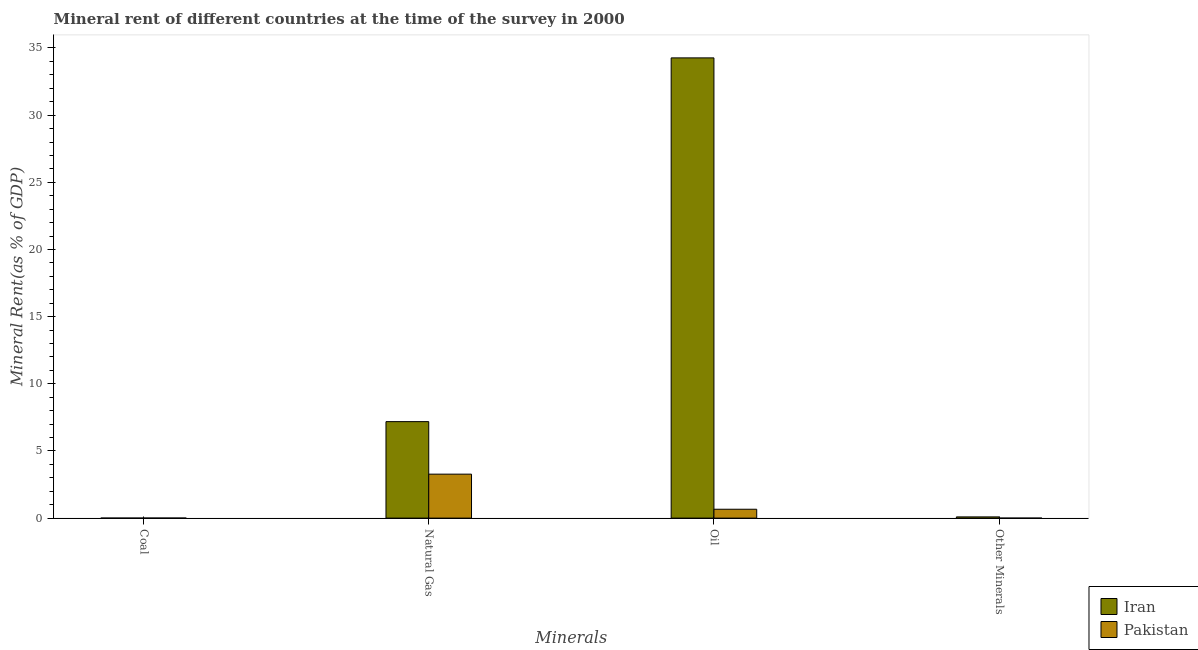How many different coloured bars are there?
Provide a short and direct response. 2. Are the number of bars per tick equal to the number of legend labels?
Give a very brief answer. Yes. How many bars are there on the 2nd tick from the left?
Your answer should be compact. 2. How many bars are there on the 1st tick from the right?
Offer a very short reply. 2. What is the label of the 2nd group of bars from the left?
Offer a very short reply. Natural Gas. What is the  rent of other minerals in Iran?
Keep it short and to the point. 0.09. Across all countries, what is the maximum oil rent?
Keep it short and to the point. 34.26. Across all countries, what is the minimum natural gas rent?
Provide a succinct answer. 3.27. In which country was the  rent of other minerals maximum?
Your response must be concise. Iran. In which country was the  rent of other minerals minimum?
Keep it short and to the point. Pakistan. What is the total natural gas rent in the graph?
Your answer should be compact. 10.46. What is the difference between the oil rent in Pakistan and that in Iran?
Provide a succinct answer. -33.6. What is the difference between the oil rent in Pakistan and the coal rent in Iran?
Provide a short and direct response. 0.66. What is the average natural gas rent per country?
Provide a short and direct response. 5.23. What is the difference between the coal rent and oil rent in Pakistan?
Your answer should be compact. -0.66. In how many countries, is the oil rent greater than 11 %?
Your answer should be compact. 1. What is the ratio of the coal rent in Pakistan to that in Iran?
Provide a short and direct response. 1.84. Is the  rent of other minerals in Iran less than that in Pakistan?
Offer a terse response. No. What is the difference between the highest and the second highest  rent of other minerals?
Provide a succinct answer. 0.09. What is the difference between the highest and the lowest coal rent?
Your answer should be very brief. 0. Is the sum of the oil rent in Iran and Pakistan greater than the maximum  rent of other minerals across all countries?
Offer a very short reply. Yes. Is it the case that in every country, the sum of the coal rent and natural gas rent is greater than the sum of  rent of other minerals and oil rent?
Give a very brief answer. No. What does the 2nd bar from the right in Coal represents?
Provide a short and direct response. Iran. Is it the case that in every country, the sum of the coal rent and natural gas rent is greater than the oil rent?
Your response must be concise. No. How many countries are there in the graph?
Offer a very short reply. 2. Are the values on the major ticks of Y-axis written in scientific E-notation?
Provide a succinct answer. No. Does the graph contain grids?
Offer a very short reply. No. How many legend labels are there?
Offer a terse response. 2. How are the legend labels stacked?
Keep it short and to the point. Vertical. What is the title of the graph?
Provide a short and direct response. Mineral rent of different countries at the time of the survey in 2000. What is the label or title of the X-axis?
Provide a short and direct response. Minerals. What is the label or title of the Y-axis?
Your answer should be compact. Mineral Rent(as % of GDP). What is the Mineral Rent(as % of GDP) of Iran in Coal?
Give a very brief answer. 0. What is the Mineral Rent(as % of GDP) in Pakistan in Coal?
Offer a very short reply. 0. What is the Mineral Rent(as % of GDP) in Iran in Natural Gas?
Ensure brevity in your answer.  7.18. What is the Mineral Rent(as % of GDP) in Pakistan in Natural Gas?
Keep it short and to the point. 3.27. What is the Mineral Rent(as % of GDP) in Iran in Oil?
Provide a short and direct response. 34.26. What is the Mineral Rent(as % of GDP) in Pakistan in Oil?
Offer a very short reply. 0.66. What is the Mineral Rent(as % of GDP) of Iran in Other Minerals?
Your answer should be very brief. 0.09. What is the Mineral Rent(as % of GDP) of Pakistan in Other Minerals?
Ensure brevity in your answer.  0. Across all Minerals, what is the maximum Mineral Rent(as % of GDP) of Iran?
Provide a short and direct response. 34.26. Across all Minerals, what is the maximum Mineral Rent(as % of GDP) of Pakistan?
Make the answer very short. 3.27. Across all Minerals, what is the minimum Mineral Rent(as % of GDP) of Iran?
Your answer should be very brief. 0. Across all Minerals, what is the minimum Mineral Rent(as % of GDP) in Pakistan?
Your answer should be very brief. 0. What is the total Mineral Rent(as % of GDP) in Iran in the graph?
Your response must be concise. 41.54. What is the total Mineral Rent(as % of GDP) of Pakistan in the graph?
Your answer should be compact. 3.94. What is the difference between the Mineral Rent(as % of GDP) in Iran in Coal and that in Natural Gas?
Give a very brief answer. -7.18. What is the difference between the Mineral Rent(as % of GDP) in Pakistan in Coal and that in Natural Gas?
Provide a succinct answer. -3.27. What is the difference between the Mineral Rent(as % of GDP) of Iran in Coal and that in Oil?
Make the answer very short. -34.26. What is the difference between the Mineral Rent(as % of GDP) of Pakistan in Coal and that in Oil?
Make the answer very short. -0.66. What is the difference between the Mineral Rent(as % of GDP) in Iran in Coal and that in Other Minerals?
Offer a terse response. -0.09. What is the difference between the Mineral Rent(as % of GDP) of Pakistan in Coal and that in Other Minerals?
Your response must be concise. 0. What is the difference between the Mineral Rent(as % of GDP) of Iran in Natural Gas and that in Oil?
Keep it short and to the point. -27.08. What is the difference between the Mineral Rent(as % of GDP) in Pakistan in Natural Gas and that in Oil?
Provide a short and direct response. 2.61. What is the difference between the Mineral Rent(as % of GDP) in Iran in Natural Gas and that in Other Minerals?
Keep it short and to the point. 7.09. What is the difference between the Mineral Rent(as % of GDP) in Pakistan in Natural Gas and that in Other Minerals?
Keep it short and to the point. 3.27. What is the difference between the Mineral Rent(as % of GDP) in Iran in Oil and that in Other Minerals?
Your answer should be compact. 34.17. What is the difference between the Mineral Rent(as % of GDP) in Pakistan in Oil and that in Other Minerals?
Your response must be concise. 0.66. What is the difference between the Mineral Rent(as % of GDP) in Iran in Coal and the Mineral Rent(as % of GDP) in Pakistan in Natural Gas?
Offer a very short reply. -3.27. What is the difference between the Mineral Rent(as % of GDP) of Iran in Coal and the Mineral Rent(as % of GDP) of Pakistan in Oil?
Offer a terse response. -0.66. What is the difference between the Mineral Rent(as % of GDP) in Iran in Coal and the Mineral Rent(as % of GDP) in Pakistan in Other Minerals?
Your answer should be very brief. 0. What is the difference between the Mineral Rent(as % of GDP) of Iran in Natural Gas and the Mineral Rent(as % of GDP) of Pakistan in Oil?
Keep it short and to the point. 6.52. What is the difference between the Mineral Rent(as % of GDP) of Iran in Natural Gas and the Mineral Rent(as % of GDP) of Pakistan in Other Minerals?
Your answer should be very brief. 7.18. What is the difference between the Mineral Rent(as % of GDP) in Iran in Oil and the Mineral Rent(as % of GDP) in Pakistan in Other Minerals?
Offer a very short reply. 34.26. What is the average Mineral Rent(as % of GDP) in Iran per Minerals?
Provide a short and direct response. 10.38. What is the difference between the Mineral Rent(as % of GDP) of Iran and Mineral Rent(as % of GDP) of Pakistan in Coal?
Offer a very short reply. -0. What is the difference between the Mineral Rent(as % of GDP) of Iran and Mineral Rent(as % of GDP) of Pakistan in Natural Gas?
Offer a very short reply. 3.91. What is the difference between the Mineral Rent(as % of GDP) of Iran and Mineral Rent(as % of GDP) of Pakistan in Oil?
Your answer should be very brief. 33.6. What is the difference between the Mineral Rent(as % of GDP) of Iran and Mineral Rent(as % of GDP) of Pakistan in Other Minerals?
Offer a very short reply. 0.09. What is the ratio of the Mineral Rent(as % of GDP) of Iran in Coal to that in Natural Gas?
Provide a succinct answer. 0. What is the ratio of the Mineral Rent(as % of GDP) of Pakistan in Coal to that in Natural Gas?
Ensure brevity in your answer.  0. What is the ratio of the Mineral Rent(as % of GDP) in Pakistan in Coal to that in Oil?
Provide a succinct answer. 0.01. What is the ratio of the Mineral Rent(as % of GDP) in Iran in Coal to that in Other Minerals?
Offer a terse response. 0.03. What is the ratio of the Mineral Rent(as % of GDP) of Pakistan in Coal to that in Other Minerals?
Ensure brevity in your answer.  27.02. What is the ratio of the Mineral Rent(as % of GDP) in Iran in Natural Gas to that in Oil?
Your answer should be compact. 0.21. What is the ratio of the Mineral Rent(as % of GDP) in Pakistan in Natural Gas to that in Oil?
Your answer should be compact. 4.95. What is the ratio of the Mineral Rent(as % of GDP) of Iran in Natural Gas to that in Other Minerals?
Your answer should be very brief. 79.19. What is the ratio of the Mineral Rent(as % of GDP) of Pakistan in Natural Gas to that in Other Minerals?
Provide a succinct answer. 1.98e+04. What is the ratio of the Mineral Rent(as % of GDP) of Iran in Oil to that in Other Minerals?
Provide a short and direct response. 377.72. What is the ratio of the Mineral Rent(as % of GDP) of Pakistan in Oil to that in Other Minerals?
Your answer should be compact. 3990.51. What is the difference between the highest and the second highest Mineral Rent(as % of GDP) of Iran?
Give a very brief answer. 27.08. What is the difference between the highest and the second highest Mineral Rent(as % of GDP) in Pakistan?
Offer a very short reply. 2.61. What is the difference between the highest and the lowest Mineral Rent(as % of GDP) in Iran?
Provide a short and direct response. 34.26. What is the difference between the highest and the lowest Mineral Rent(as % of GDP) of Pakistan?
Your response must be concise. 3.27. 